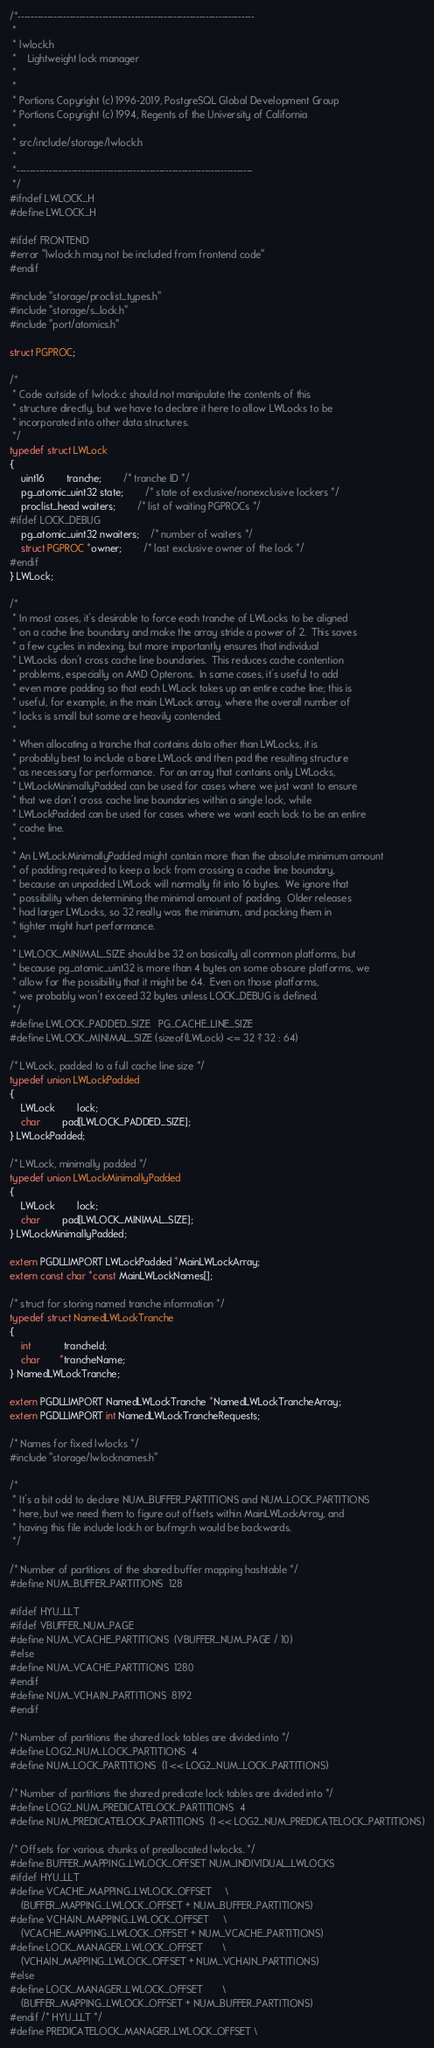Convert code to text. <code><loc_0><loc_0><loc_500><loc_500><_C_>/*-------------------------------------------------------------------------
 *
 * lwlock.h
 *	  Lightweight lock manager
 *
 *
 * Portions Copyright (c) 1996-2019, PostgreSQL Global Development Group
 * Portions Copyright (c) 1994, Regents of the University of California
 *
 * src/include/storage/lwlock.h
 *
 *-------------------------------------------------------------------------
 */
#ifndef LWLOCK_H
#define LWLOCK_H

#ifdef FRONTEND
#error "lwlock.h may not be included from frontend code"
#endif

#include "storage/proclist_types.h"
#include "storage/s_lock.h"
#include "port/atomics.h"

struct PGPROC;

/*
 * Code outside of lwlock.c should not manipulate the contents of this
 * structure directly, but we have to declare it here to allow LWLocks to be
 * incorporated into other data structures.
 */
typedef struct LWLock
{
	uint16		tranche;		/* tranche ID */
	pg_atomic_uint32 state;		/* state of exclusive/nonexclusive lockers */
	proclist_head waiters;		/* list of waiting PGPROCs */
#ifdef LOCK_DEBUG
	pg_atomic_uint32 nwaiters;	/* number of waiters */
	struct PGPROC *owner;		/* last exclusive owner of the lock */
#endif
} LWLock;

/*
 * In most cases, it's desirable to force each tranche of LWLocks to be aligned
 * on a cache line boundary and make the array stride a power of 2.  This saves
 * a few cycles in indexing, but more importantly ensures that individual
 * LWLocks don't cross cache line boundaries.  This reduces cache contention
 * problems, especially on AMD Opterons.  In some cases, it's useful to add
 * even more padding so that each LWLock takes up an entire cache line; this is
 * useful, for example, in the main LWLock array, where the overall number of
 * locks is small but some are heavily contended.
 *
 * When allocating a tranche that contains data other than LWLocks, it is
 * probably best to include a bare LWLock and then pad the resulting structure
 * as necessary for performance.  For an array that contains only LWLocks,
 * LWLockMinimallyPadded can be used for cases where we just want to ensure
 * that we don't cross cache line boundaries within a single lock, while
 * LWLockPadded can be used for cases where we want each lock to be an entire
 * cache line.
 *
 * An LWLockMinimallyPadded might contain more than the absolute minimum amount
 * of padding required to keep a lock from crossing a cache line boundary,
 * because an unpadded LWLock will normally fit into 16 bytes.  We ignore that
 * possibility when determining the minimal amount of padding.  Older releases
 * had larger LWLocks, so 32 really was the minimum, and packing them in
 * tighter might hurt performance.
 *
 * LWLOCK_MINIMAL_SIZE should be 32 on basically all common platforms, but
 * because pg_atomic_uint32 is more than 4 bytes on some obscure platforms, we
 * allow for the possibility that it might be 64.  Even on those platforms,
 * we probably won't exceed 32 bytes unless LOCK_DEBUG is defined.
 */
#define LWLOCK_PADDED_SIZE	PG_CACHE_LINE_SIZE
#define LWLOCK_MINIMAL_SIZE (sizeof(LWLock) <= 32 ? 32 : 64)

/* LWLock, padded to a full cache line size */
typedef union LWLockPadded
{
	LWLock		lock;
	char		pad[LWLOCK_PADDED_SIZE];
} LWLockPadded;

/* LWLock, minimally padded */
typedef union LWLockMinimallyPadded
{
	LWLock		lock;
	char		pad[LWLOCK_MINIMAL_SIZE];
} LWLockMinimallyPadded;

extern PGDLLIMPORT LWLockPadded *MainLWLockArray;
extern const char *const MainLWLockNames[];

/* struct for storing named tranche information */
typedef struct NamedLWLockTranche
{
	int			trancheId;
	char	   *trancheName;
} NamedLWLockTranche;

extern PGDLLIMPORT NamedLWLockTranche *NamedLWLockTrancheArray;
extern PGDLLIMPORT int NamedLWLockTrancheRequests;

/* Names for fixed lwlocks */
#include "storage/lwlocknames.h"

/*
 * It's a bit odd to declare NUM_BUFFER_PARTITIONS and NUM_LOCK_PARTITIONS
 * here, but we need them to figure out offsets within MainLWLockArray, and
 * having this file include lock.h or bufmgr.h would be backwards.
 */

/* Number of partitions of the shared buffer mapping hashtable */
#define NUM_BUFFER_PARTITIONS  128

#ifdef HYU_LLT
#ifdef VBUFFER_NUM_PAGE
#define NUM_VCACHE_PARTITIONS  (VBUFFER_NUM_PAGE / 10)
#else
#define NUM_VCACHE_PARTITIONS  1280
#endif
#define NUM_VCHAIN_PARTITIONS  8192
#endif

/* Number of partitions the shared lock tables are divided into */
#define LOG2_NUM_LOCK_PARTITIONS  4
#define NUM_LOCK_PARTITIONS  (1 << LOG2_NUM_LOCK_PARTITIONS)

/* Number of partitions the shared predicate lock tables are divided into */
#define LOG2_NUM_PREDICATELOCK_PARTITIONS  4
#define NUM_PREDICATELOCK_PARTITIONS  (1 << LOG2_NUM_PREDICATELOCK_PARTITIONS)

/* Offsets for various chunks of preallocated lwlocks. */
#define BUFFER_MAPPING_LWLOCK_OFFSET	NUM_INDIVIDUAL_LWLOCKS
#ifdef HYU_LLT
#define VCACHE_MAPPING_LWLOCK_OFFSET		\
	(BUFFER_MAPPING_LWLOCK_OFFSET + NUM_BUFFER_PARTITIONS)
#define VCHAIN_MAPPING_LWLOCK_OFFSET		\
	(VCACHE_MAPPING_LWLOCK_OFFSET + NUM_VCACHE_PARTITIONS)
#define LOCK_MANAGER_LWLOCK_OFFSET		\
	(VCHAIN_MAPPING_LWLOCK_OFFSET + NUM_VCHAIN_PARTITIONS)
#else
#define LOCK_MANAGER_LWLOCK_OFFSET		\
	(BUFFER_MAPPING_LWLOCK_OFFSET + NUM_BUFFER_PARTITIONS)
#endif /* HYU_LLT */
#define PREDICATELOCK_MANAGER_LWLOCK_OFFSET \</code> 